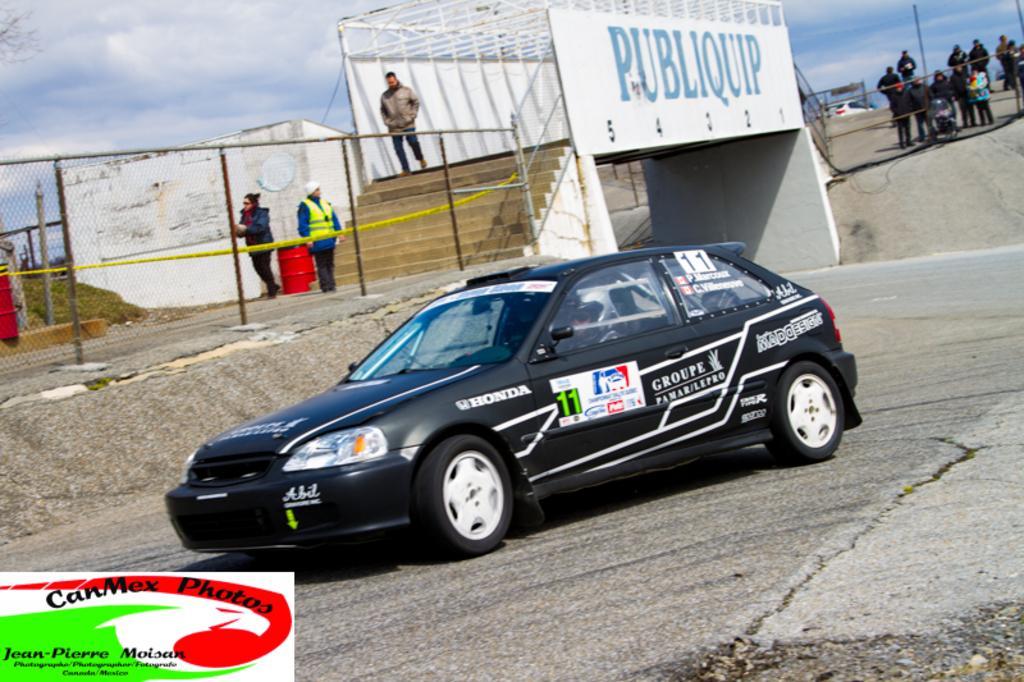Describe this image in one or two sentences. In the middle it is a car in black color, here a man is walking, it is a bridge in this image. On the right side a few people are standing and looking at this side. 